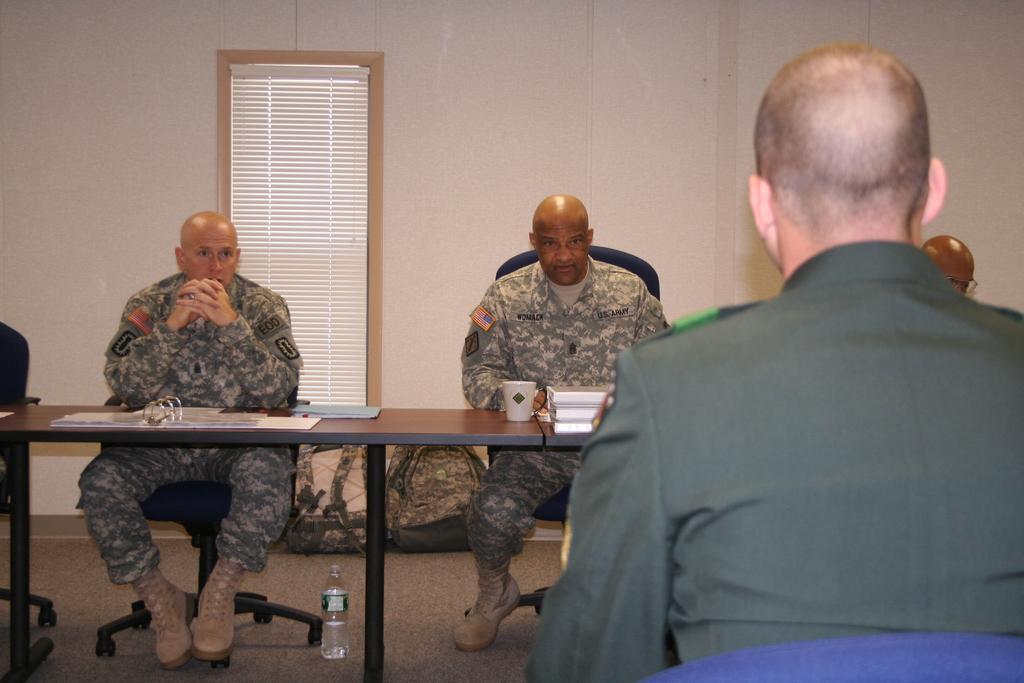How would you summarize this image in a sentence or two? In this picture we can see three persons sitting on the chairs. This is table. On the table there is a cup. And this is bottle. On the background we can see a wall and these are the bags. 